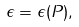<formula> <loc_0><loc_0><loc_500><loc_500>\epsilon = \epsilon ( P ) ,</formula> 